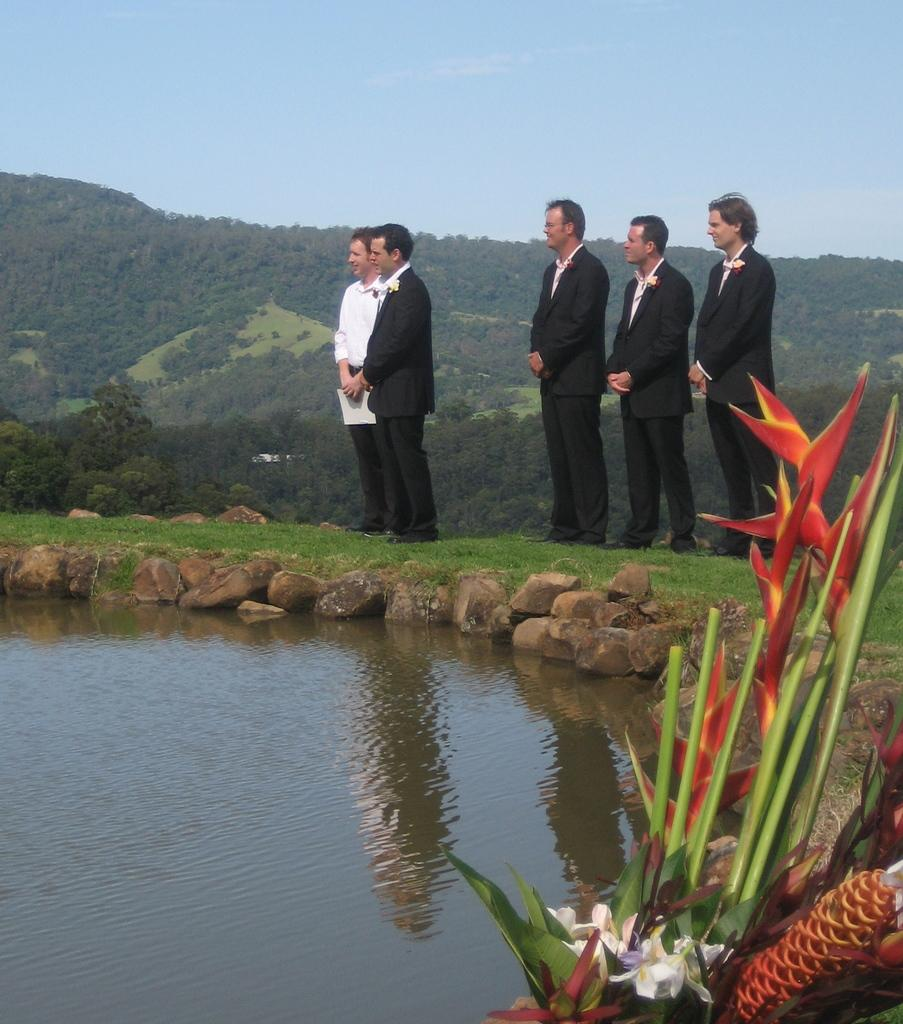What is the surface that the people are standing on in the image? The people are standing on the grass in the image. What can be seen in the distance behind the people? There is water, flowers, small stones, mountains, and trees visible in the background. What type of skin condition can be seen on the people in the image? There is no indication of any skin condition on the people in the image. Can you tell me how many people are swimming in the water in the image? There is no water visible in the image; it is in the background. Additionally, there are no people swimming in the image. 